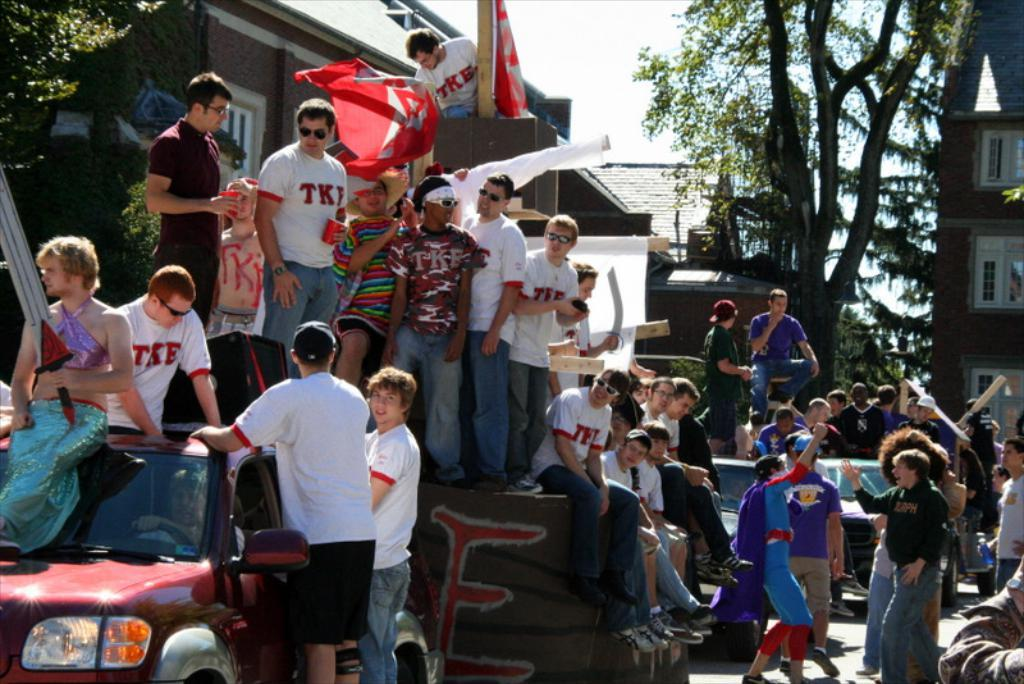What are the people in the image doing with the car? There are people sitting in a car and sitting on a car. What can be seen on the object behind the car? There are people standing on an object behind the car. What is visible in the distance behind the car? There are people, buildings, and trees visible in the background. What type of wrench is being used by the person sitting in the car? There is no wrench present in the image; the people are sitting in and on the car, not working on it. How many times does the person standing on the object behind the car cough in the image? There is no indication of anyone coughing in the image. 